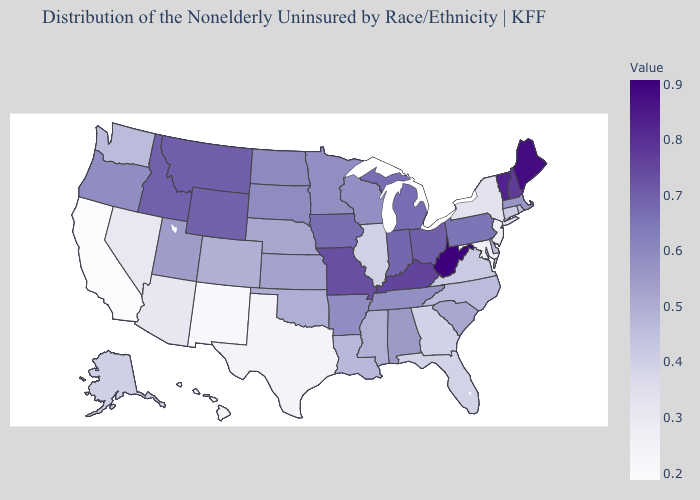Which states hav the highest value in the West?
Concise answer only. Montana. Does New York have a higher value than Oklahoma?
Quick response, please. No. Does New Jersey have a higher value than Tennessee?
Quick response, please. No. Does Michigan have a higher value than Maine?
Give a very brief answer. No. Does Minnesota have the highest value in the USA?
Keep it brief. No. Among the states that border Georgia , which have the lowest value?
Write a very short answer. Florida. Which states have the lowest value in the South?
Keep it brief. Texas. 